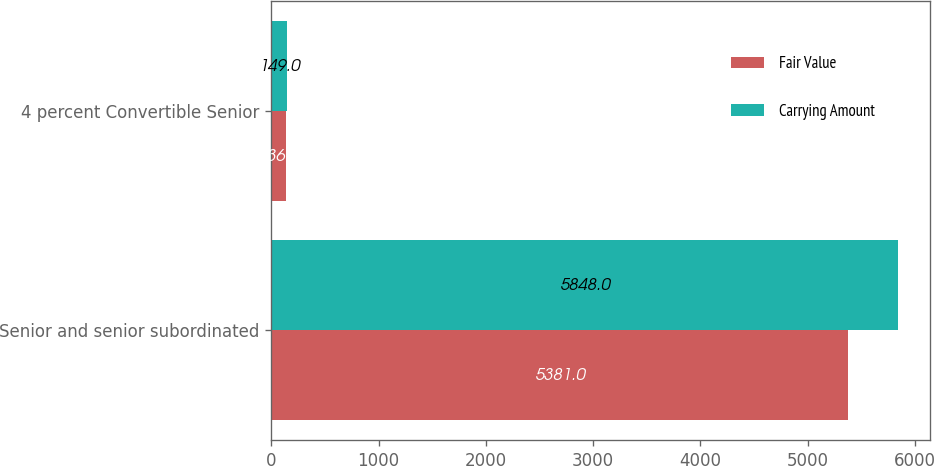<chart> <loc_0><loc_0><loc_500><loc_500><stacked_bar_chart><ecel><fcel>Senior and senior subordinated<fcel>4 percent Convertible Senior<nl><fcel>Fair Value<fcel>5381<fcel>136<nl><fcel>Carrying Amount<fcel>5848<fcel>149<nl></chart> 